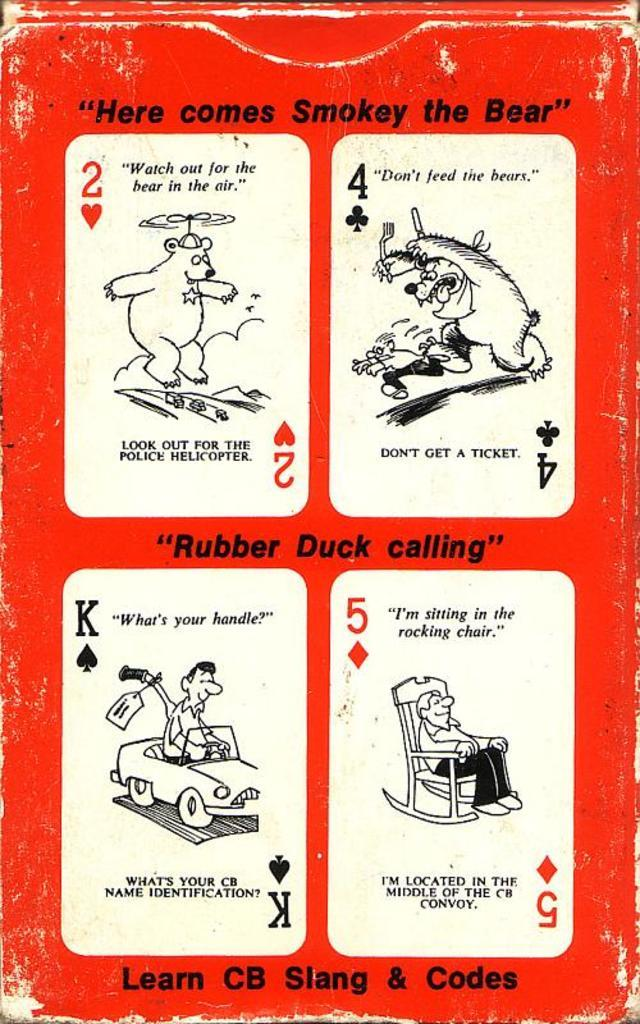What is featured on the poster in the image? The poster contains cartoon images of a bear and three persons. What type of images are on the poster? The images on the poster are cartoon images. What else can be found on the poster besides the images? There is text on the poster. What type of bread is being used to start a fire in the image? There is no bread or fire present in the image; it only features a poster with cartoon images and text. 